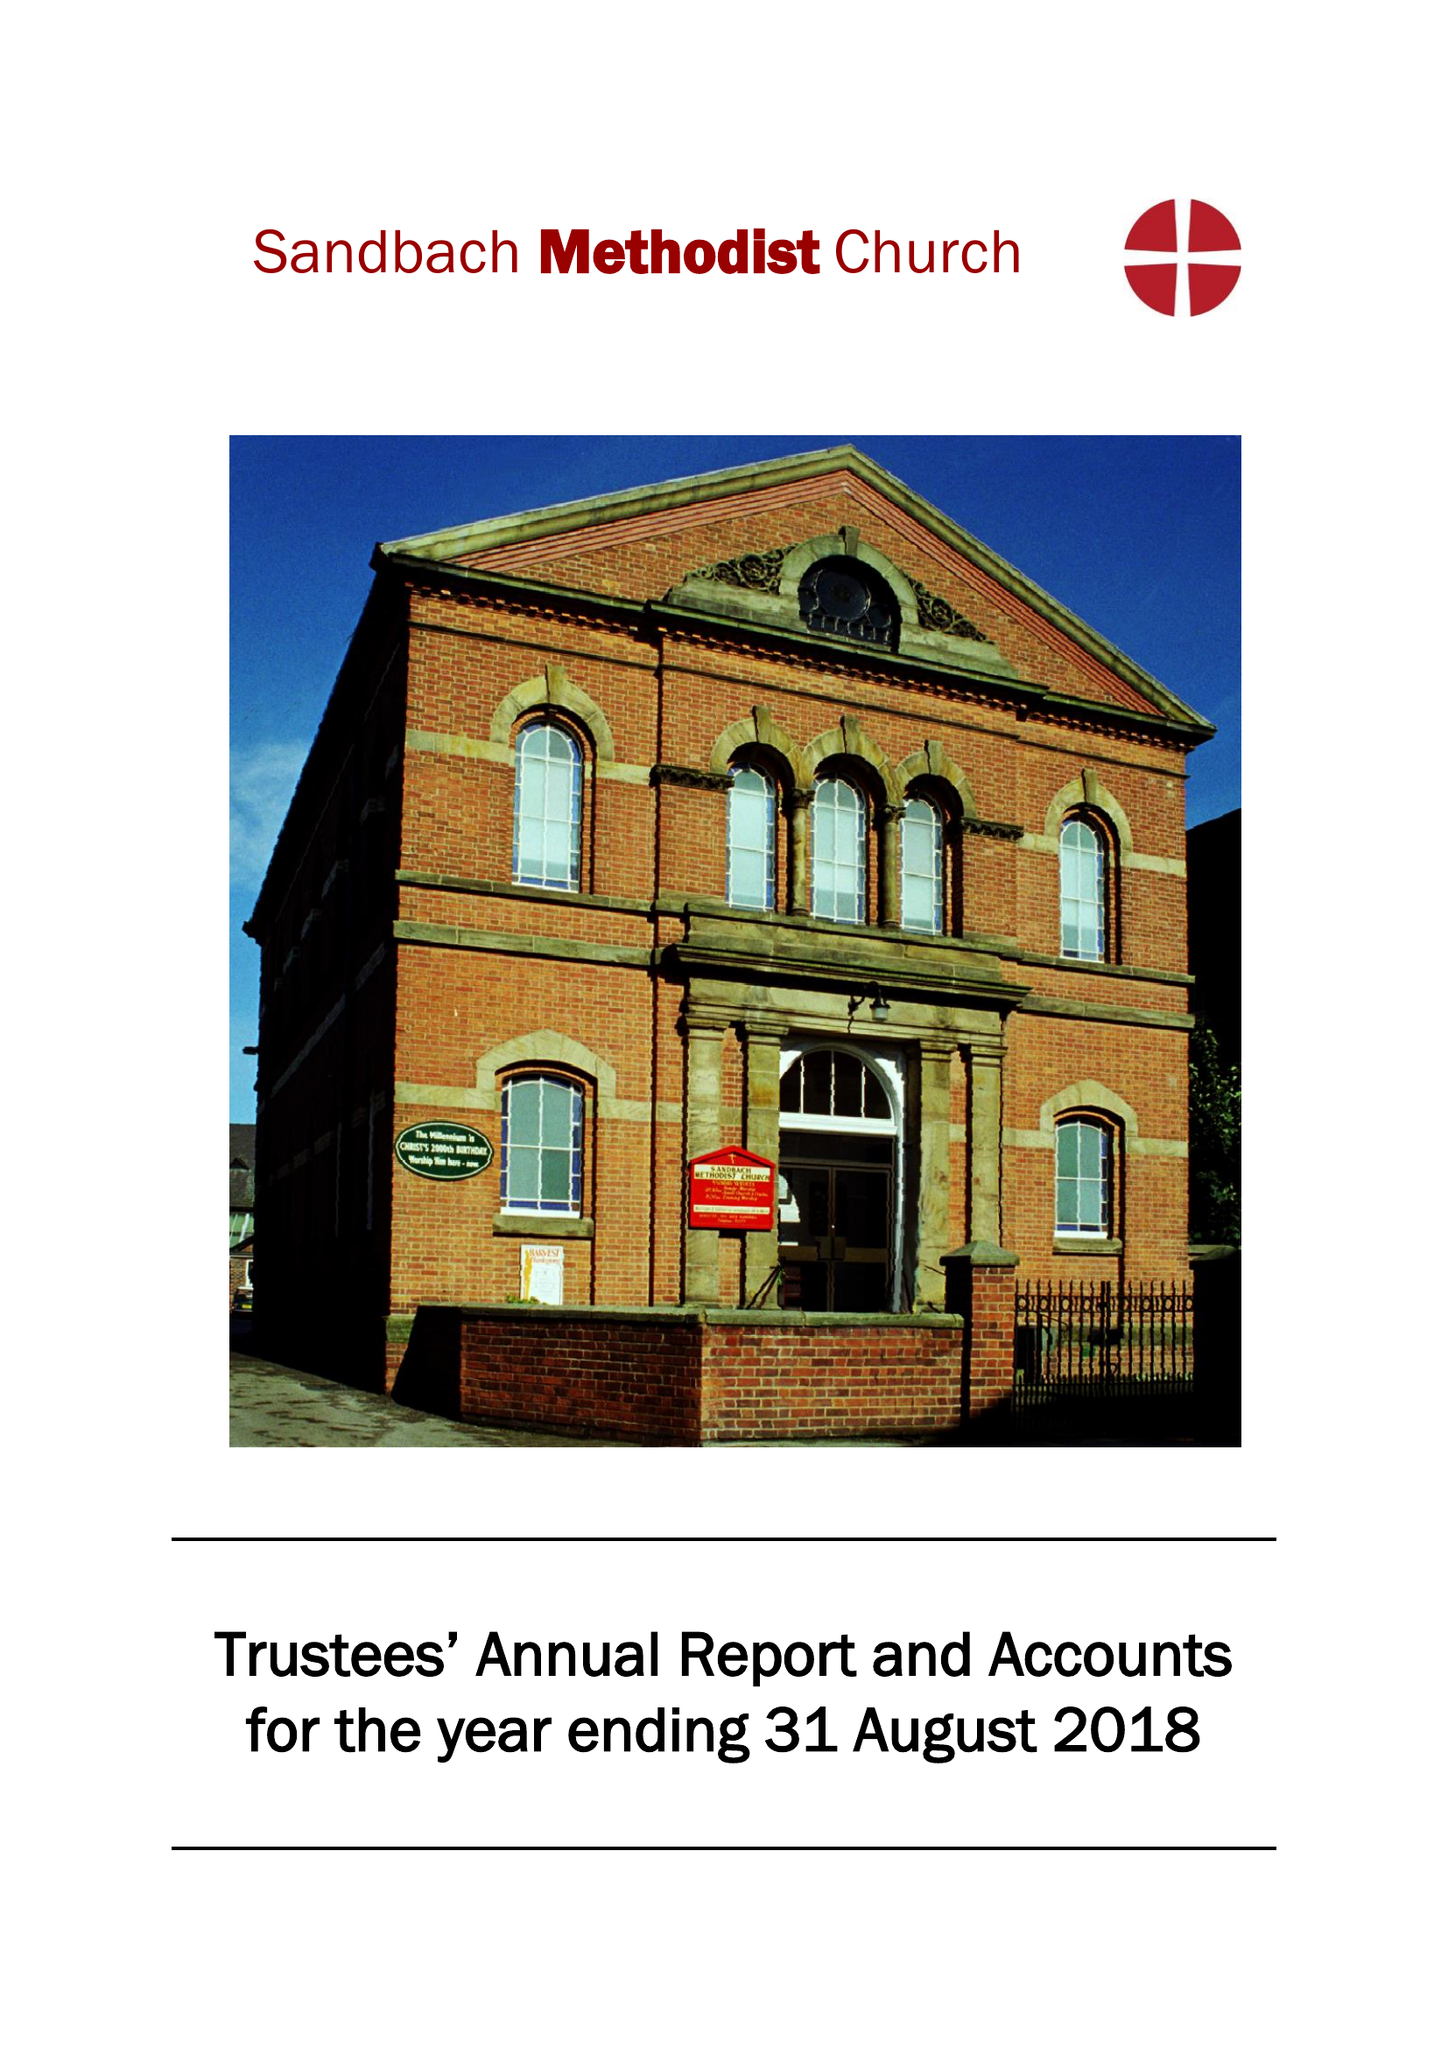What is the value for the report_date?
Answer the question using a single word or phrase. 2018-08-31 